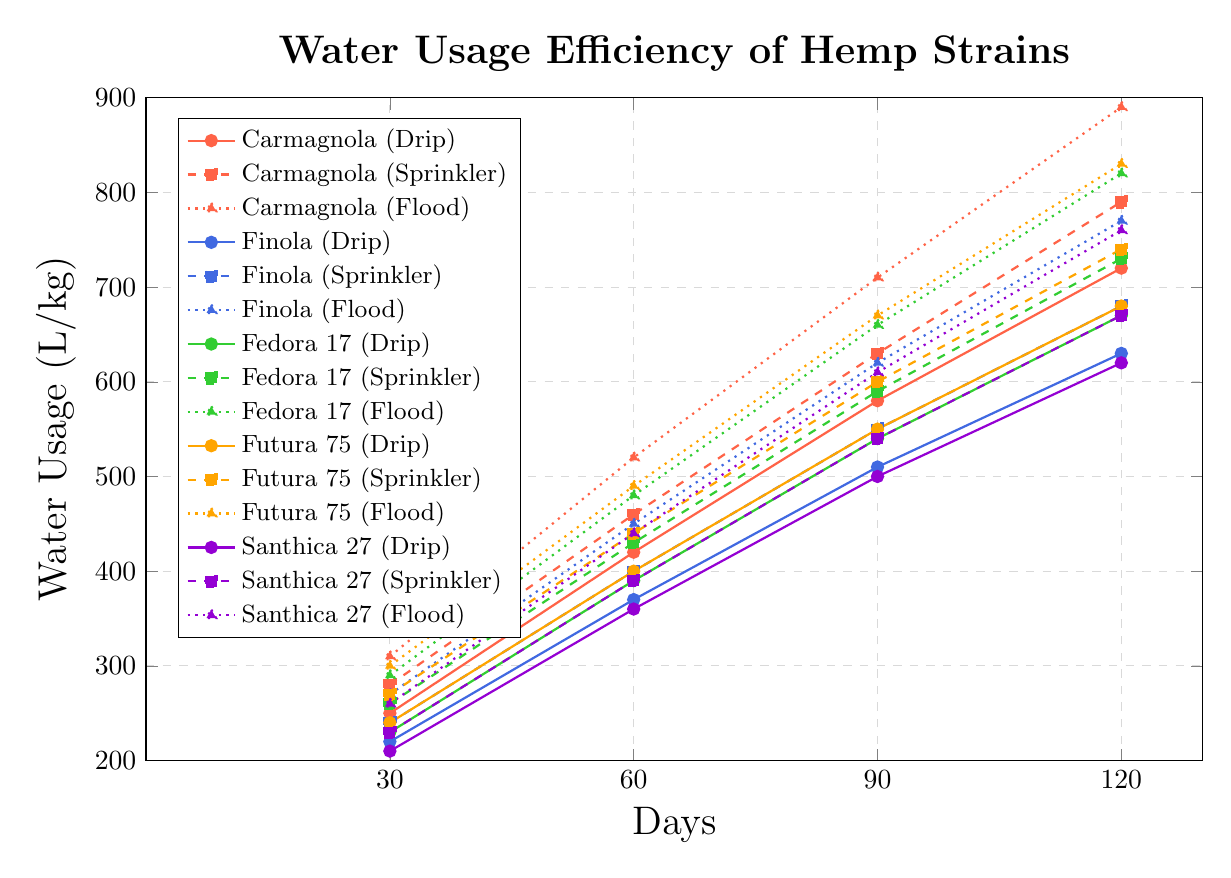What's the average water usage for Carmagnola under flood irrigation over the growing cycle? First, find the water usage values for Carmagnola under flood irrigation (310, 520, 710, 890). Sum these values (310 + 520 + 710 + 890 = 2430). Then, divide by the number of data points (2430 / 4 = 607.5).
Answer: 607.5 Which strain had the highest water usage under flood irrigation at day 90? Compare the water usage at day 90 for each strain under flood irrigation: Carmagnola (710), Finola (620), Fedora 17 (660), Futura 75 (670), Santhica 27 (610). Carmagnola has the highest value (710).
Answer: Carmagnola How does the water usage efficiency of Finola under drip irrigation compare to Santhica 27 under the same method at day 60? Find the water usage values at day 60: Finola under drip (370) and Santhica 27 under drip (360). Finola uses 10 L/kg more than Santhica 27 (370 - 360 = 10).
Answer: Finola uses 10 L/kg more What's the total water usage for Santhica 27 under sprinkler irrigation throughout the growing cycle? Sum the water usage values for Santhica 27 under sprinkler irrigation: (230 + 390 + 540 + 670). The total is 1830 L/kg (230 + 390 + 540 + 670 = 1830).
Answer: 1830 On day 120, which strain has the least efficient water usage under drip irrigation? Compare the water usage values at day 120 for each strain under drip irrigation: Carmagnola (720), Finola (630), Fedora 17 (670), Futura 75 (680), Santhica 27 (620). Carmagnola has the highest value, indicating the least efficiency.
Answer: Carmagnola What's the average difference in water usage between drip and sprinkler irrigation for Fedora 17 over the growing cycle? Find the differences at each time point: (230-260, 390-430, 540-590, 670-730). Sum the absolute differences: (30 + 40 + 50 + 60 = 180). Divide by the number of data points (180 / 4 = 45).
Answer: 45 Which irrigation technique results in the most efficient water usage for Futura 75 at day 30? Compare the water usage values at day 30 for Futura 75 across all irrigation techniques: Drip (240), Sprinkler (270), Flood (300). The least value indicates the most efficiency.
Answer: Drip What's the range of water usage for Finola under flood irrigation over the growth cycle? Find the minimum and maximum values of water usage for Finola under flood irrigation (270 and 770 respectively). Calculate the range (770 - 270 = 500).
Answer: 500 If you average the water usage of all strains under drip irrigation at day 60, what is the result? Sum the water usage values for all strains under drip irrigation at day 60 (420 + 370 + 390 + 400 + 360 = 1940). Divide by the number of strains (1940 / 5 = 388).
Answer: 388 